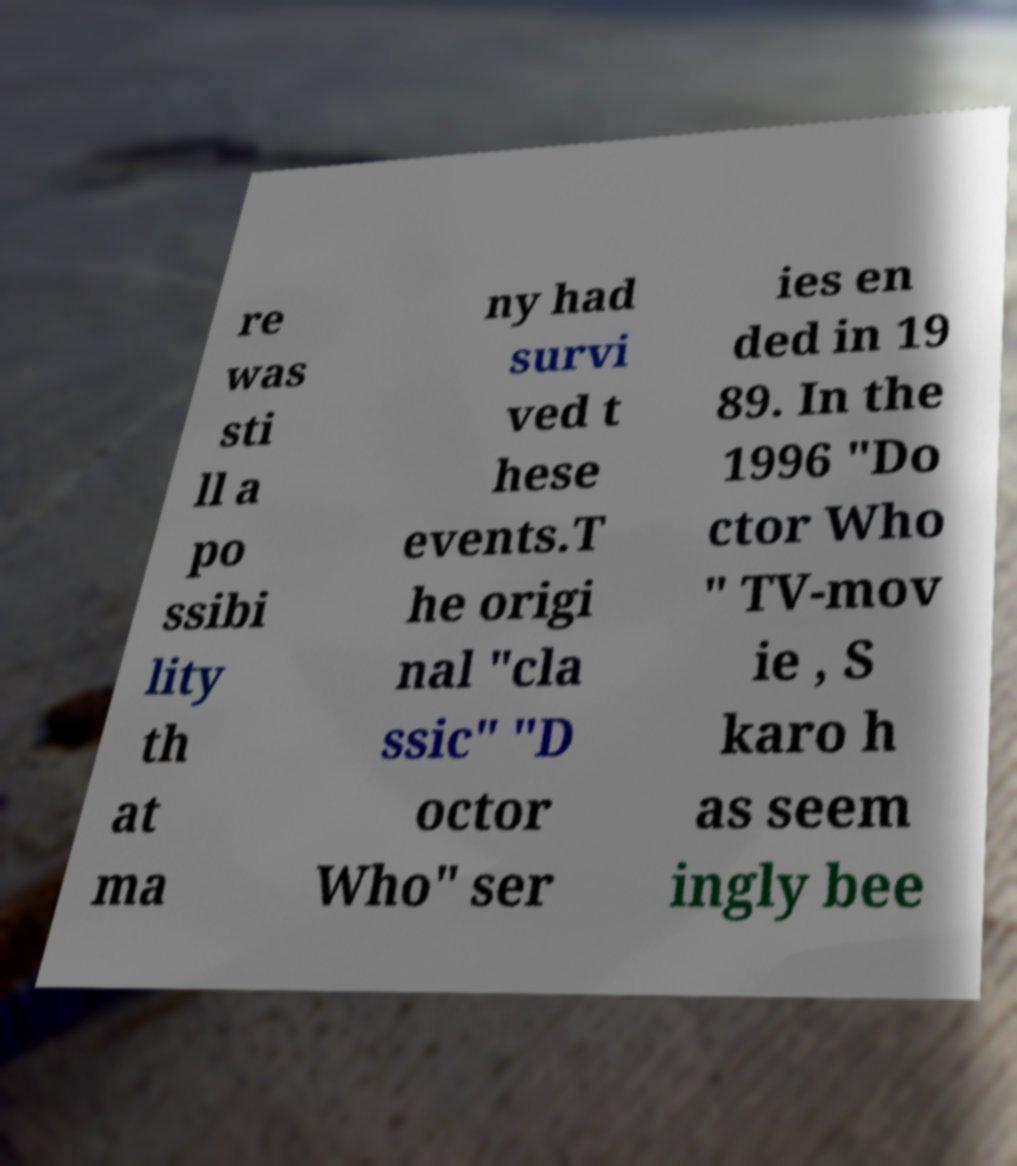Please read and relay the text visible in this image. What does it say? re was sti ll a po ssibi lity th at ma ny had survi ved t hese events.T he origi nal "cla ssic" "D octor Who" ser ies en ded in 19 89. In the 1996 "Do ctor Who " TV-mov ie , S karo h as seem ingly bee 